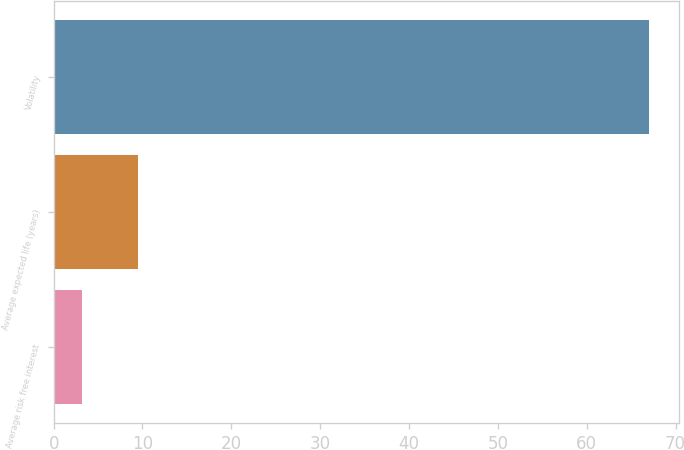Convert chart to OTSL. <chart><loc_0><loc_0><loc_500><loc_500><bar_chart><fcel>Average risk free interest<fcel>Average expected life (years)<fcel>Volatility<nl><fcel>3.14<fcel>9.53<fcel>67<nl></chart> 